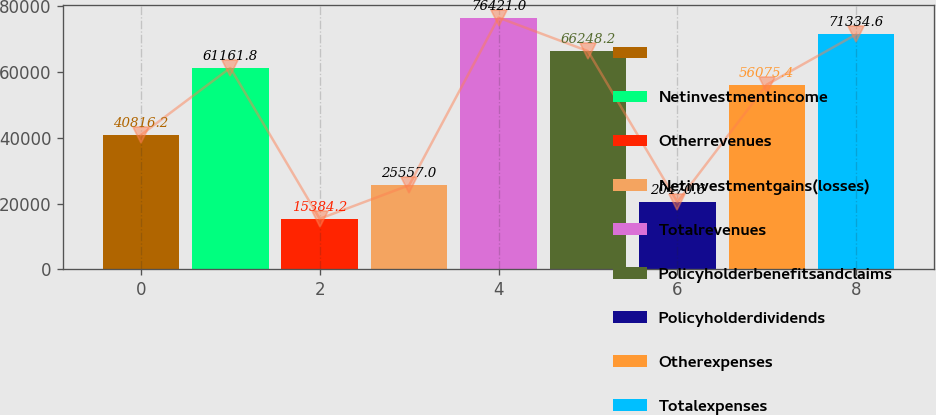Convert chart. <chart><loc_0><loc_0><loc_500><loc_500><bar_chart><ecel><fcel>Netinvestmentincome<fcel>Otherrevenues<fcel>Netinvestmentgains(losses)<fcel>Totalrevenues<fcel>Policyholderbenefitsandclaims<fcel>Policyholderdividends<fcel>Otherexpenses<fcel>Totalexpenses<nl><fcel>40816.2<fcel>61161.8<fcel>15384.2<fcel>25557<fcel>76421<fcel>66248.2<fcel>20470.6<fcel>56075.4<fcel>71334.6<nl></chart> 